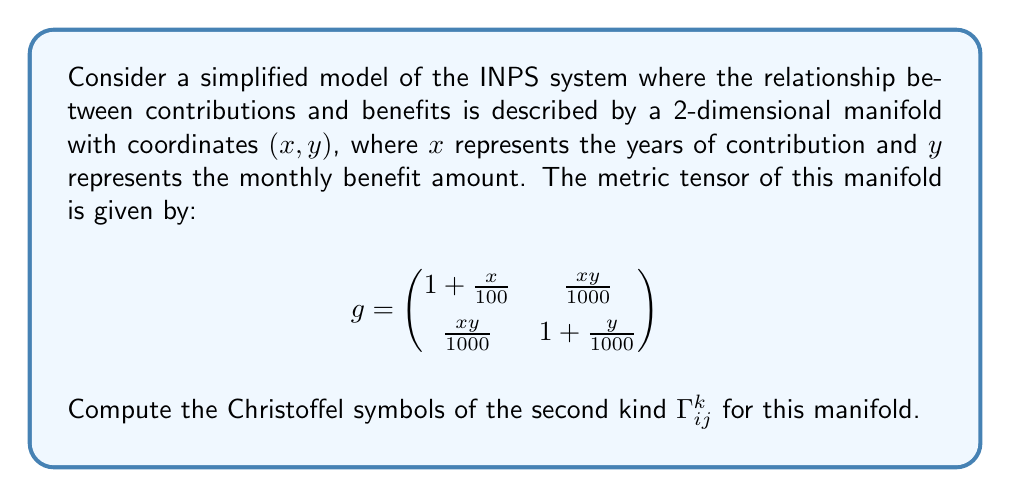What is the answer to this math problem? To compute the Christoffel symbols, we'll follow these steps:

1) First, recall the formula for Christoffel symbols of the second kind:

   $$\Gamma^k_{ij} = \frac{1}{2}g^{kl}\left(\frac{\partial g_{il}}{\partial x^j} + \frac{\partial g_{jl}}{\partial x^i} - \frac{\partial g_{ij}}{\partial x^l}\right)$$

2) We need to find the inverse of the metric tensor $g^{ij}$. The inverse is:

   $$g^{-1} = \frac{1}{\det(g)}\begin{pmatrix}
   1 + \frac{y}{1000} & -\frac{xy}{1000} \\
   -\frac{xy}{1000} & 1 + \frac{x}{100}
   \end{pmatrix}$$

   where $\det(g) = (1 + \frac{x}{100})(1 + \frac{y}{1000}) - (\frac{xy}{1000})^2$

3) Now, let's compute the partial derivatives:

   $\frac{\partial g_{11}}{\partial x} = \frac{1}{100}$, $\frac{\partial g_{11}}{\partial y} = 0$
   
   $\frac{\partial g_{12}}{\partial x} = \frac{y}{1000}$, $\frac{\partial g_{12}}{\partial y} = \frac{x}{1000}$
   
   $\frac{\partial g_{22}}{\partial x} = 0$, $\frac{\partial g_{22}}{\partial y} = \frac{1}{1000}$

4) Now we can compute each Christoffel symbol:

   $\Gamma^1_{11} = \frac{1}{2}g^{11}\frac{\partial g_{11}}{\partial x} = \frac{1}{200}(1 + \frac{y}{1000})$

   $\Gamma^1_{12} = \frac{1}{2}g^{11}\frac{\partial g_{11}}{\partial y} + \frac{1}{2}g^{11}\frac{\partial g_{12}}{\partial x} - \frac{1}{2}g^{12}\frac{\partial g_{11}}{\partial x} = \frac{y}{2000}(1 + \frac{y}{1000}) + \frac{x^2y}{200000\det(g)}$

   $\Gamma^1_{22} = g^{11}\frac{\partial g_{12}}{\partial y} - \frac{1}{2}g^{12}\frac{\partial g_{22}}{\partial y} = \frac{x}{1000}(1 + \frac{y}{1000}) - \frac{x^2y}{2000000\det(g)}$

   $\Gamma^2_{11} = g^{22}\frac{\partial g_{12}}{\partial x} - \frac{1}{2}g^{21}\frac{\partial g_{11}}{\partial x} = \frac{y}{1000}(1 + \frac{x}{100}) - \frac{x^2y}{200000\det(g)}$

   $\Gamma^2_{12} = \frac{1}{2}g^{22}\frac{\partial g_{22}}{\partial x} + \frac{1}{2}g^{22}\frac{\partial g_{12}}{\partial y} - \frac{1}{2}g^{21}\frac{\partial g_{12}}{\partial x} = \frac{x}{2000}(1 + \frac{x}{100}) + \frac{xy^2}{200000\det(g)}$

   $\Gamma^2_{22} = \frac{1}{2}g^{22}\frac{\partial g_{22}}{\partial y} = \frac{1}{2000}(1 + \frac{x}{100})$
Answer: The Christoffel symbols of the second kind for the given manifold are:

$$\Gamma^1_{11} = \frac{1}{200}(1 + \frac{y}{1000})$$

$$\Gamma^1_{12} = \Gamma^1_{21} = \frac{y}{2000}(1 + \frac{y}{1000}) + \frac{x^2y}{200000\det(g)}$$

$$\Gamma^1_{22} = \frac{x}{1000}(1 + \frac{y}{1000}) - \frac{x^2y}{2000000\det(g)}$$

$$\Gamma^2_{11} = \frac{y}{1000}(1 + \frac{x}{100}) - \frac{x^2y}{200000\det(g)}$$

$$\Gamma^2_{12} = \Gamma^2_{21} = \frac{x}{2000}(1 + \frac{x}{100}) + \frac{xy^2}{200000\det(g)}$$

$$\Gamma^2_{22} = \frac{1}{2000}(1 + \frac{x}{100})$$

where $\det(g) = (1 + \frac{x}{100})(1 + \frac{y}{1000}) - (\frac{xy}{1000})^2$ 